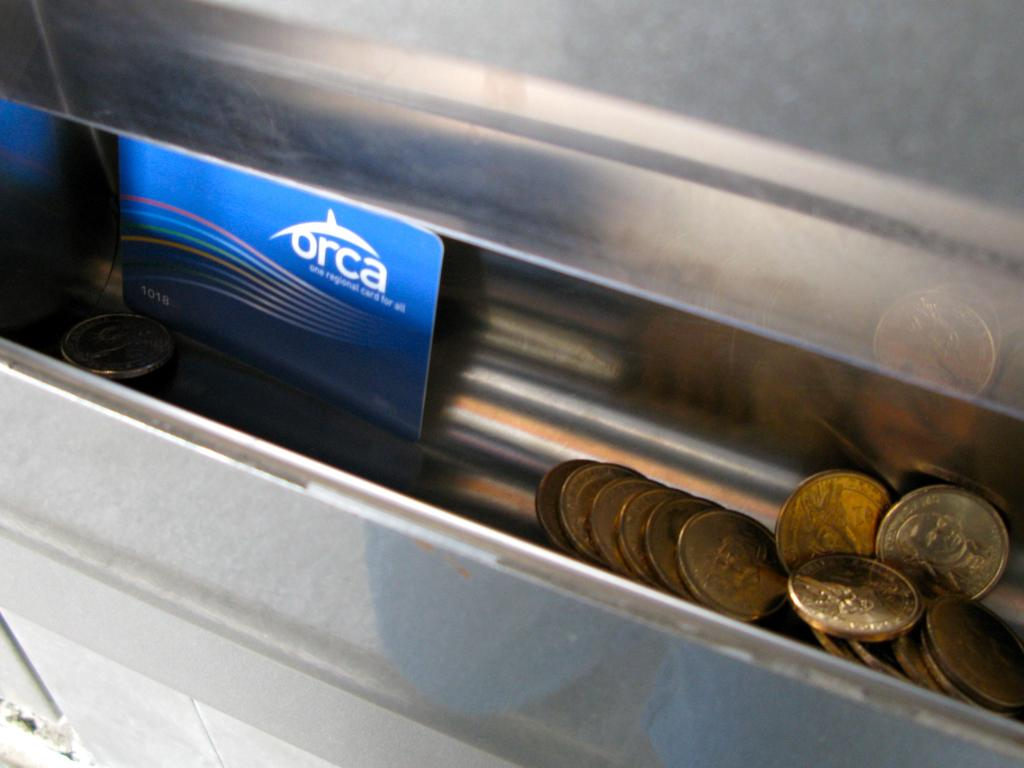<image>
Create a compact narrative representing the image presented. a slot with coins and an orca credit card 